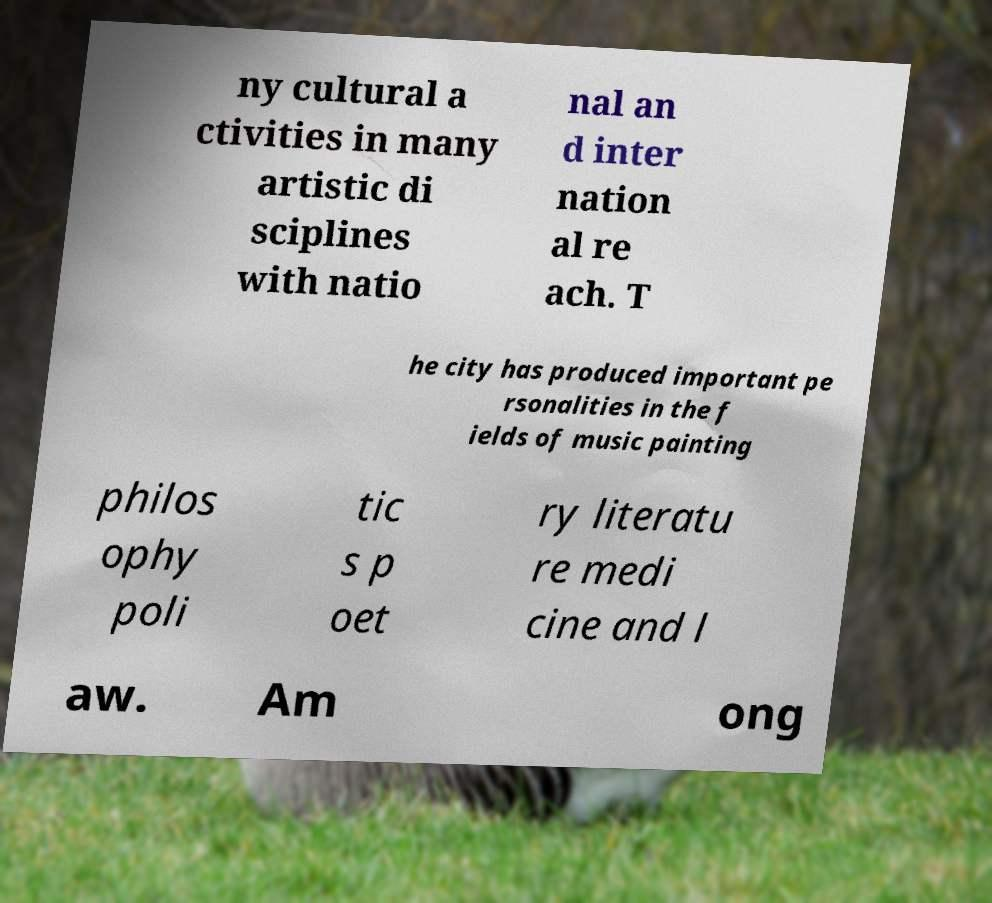What messages or text are displayed in this image? I need them in a readable, typed format. ny cultural a ctivities in many artistic di sciplines with natio nal an d inter nation al re ach. T he city has produced important pe rsonalities in the f ields of music painting philos ophy poli tic s p oet ry literatu re medi cine and l aw. Am ong 